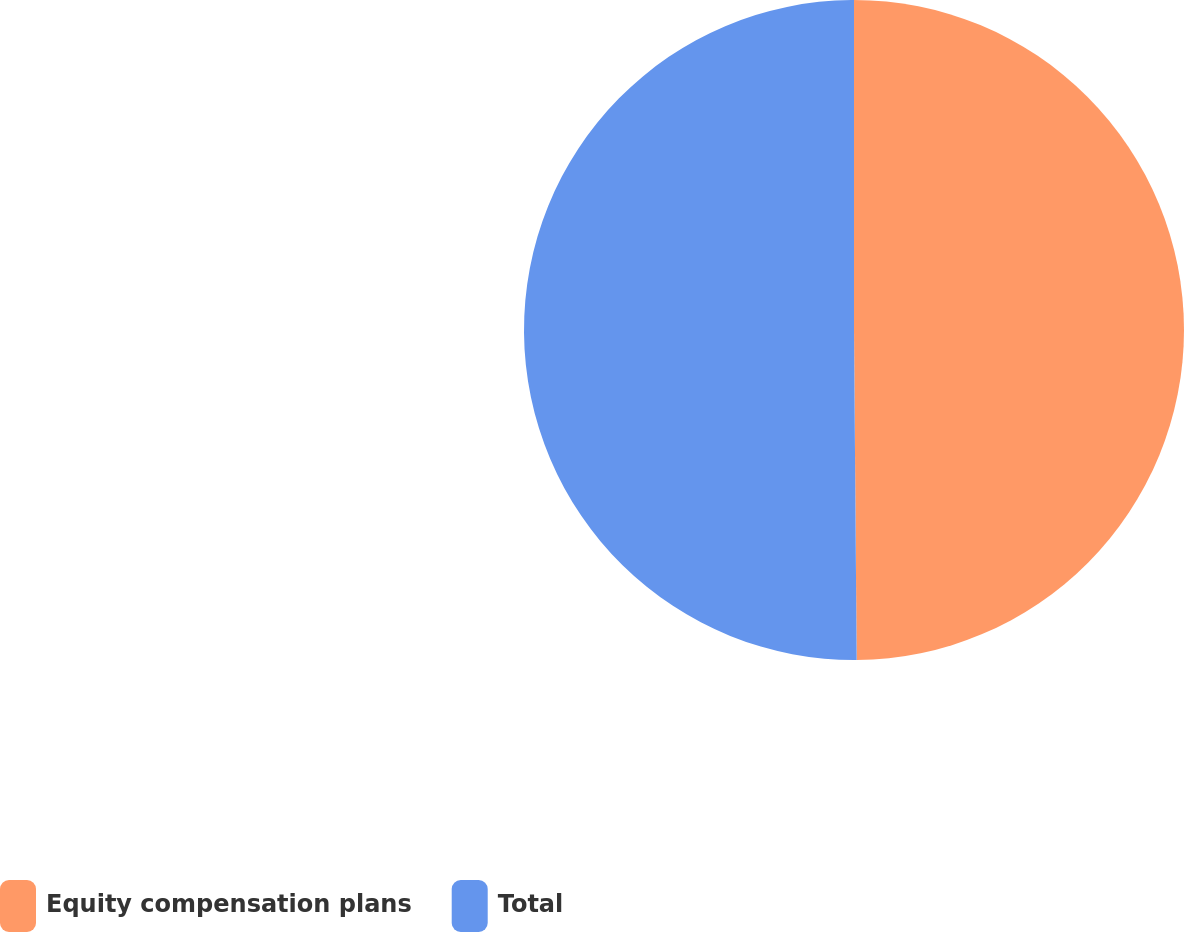Convert chart. <chart><loc_0><loc_0><loc_500><loc_500><pie_chart><fcel>Equity compensation plans<fcel>Total<nl><fcel>49.87%<fcel>50.13%<nl></chart> 